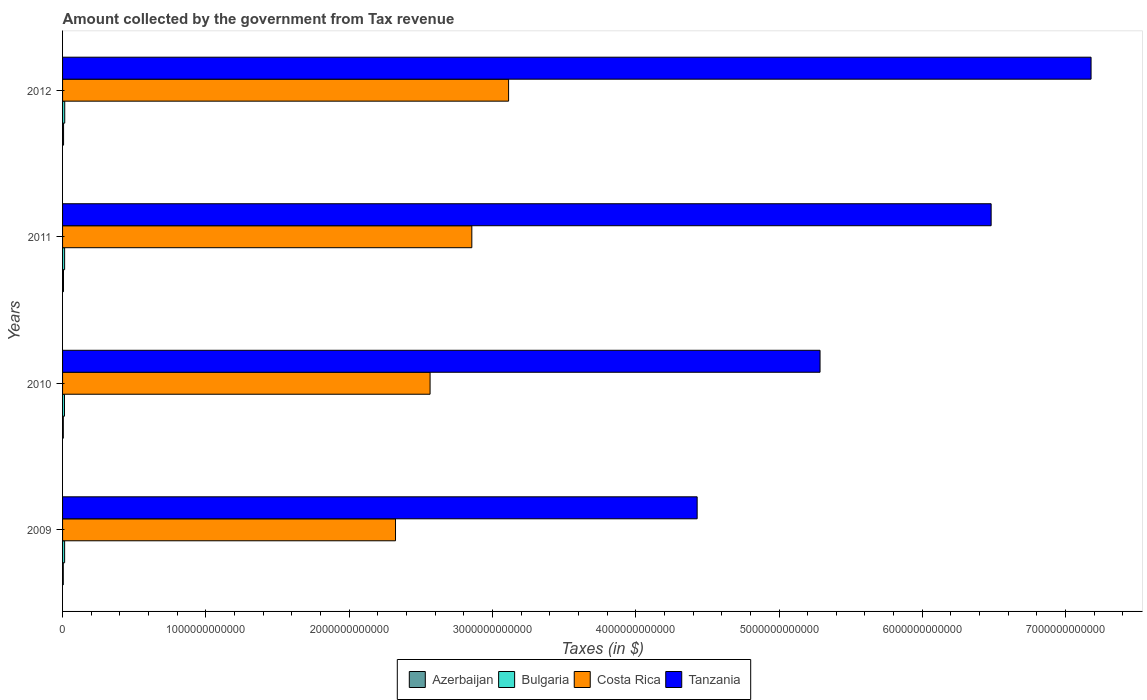How many different coloured bars are there?
Give a very brief answer. 4. How many groups of bars are there?
Ensure brevity in your answer.  4. Are the number of bars per tick equal to the number of legend labels?
Provide a short and direct response. Yes. What is the label of the 4th group of bars from the top?
Give a very brief answer. 2009. In how many cases, is the number of bars for a given year not equal to the number of legend labels?
Offer a terse response. 0. What is the amount collected by the government from tax revenue in Bulgaria in 2012?
Your answer should be compact. 1.52e+1. Across all years, what is the maximum amount collected by the government from tax revenue in Costa Rica?
Your response must be concise. 3.11e+12. Across all years, what is the minimum amount collected by the government from tax revenue in Bulgaria?
Make the answer very short. 1.35e+1. In which year was the amount collected by the government from tax revenue in Costa Rica minimum?
Offer a very short reply. 2009. What is the total amount collected by the government from tax revenue in Bulgaria in the graph?
Keep it short and to the point. 5.74e+1. What is the difference between the amount collected by the government from tax revenue in Bulgaria in 2009 and that in 2011?
Provide a short and direct response. 9.09e+06. What is the difference between the amount collected by the government from tax revenue in Azerbaijan in 2010 and the amount collected by the government from tax revenue in Bulgaria in 2012?
Keep it short and to the point. -1.00e+1. What is the average amount collected by the government from tax revenue in Bulgaria per year?
Offer a terse response. 1.43e+1. In the year 2012, what is the difference between the amount collected by the government from tax revenue in Costa Rica and amount collected by the government from tax revenue in Bulgaria?
Ensure brevity in your answer.  3.10e+12. What is the ratio of the amount collected by the government from tax revenue in Azerbaijan in 2009 to that in 2011?
Your response must be concise. 0.79. Is the amount collected by the government from tax revenue in Azerbaijan in 2009 less than that in 2011?
Your answer should be very brief. Yes. What is the difference between the highest and the second highest amount collected by the government from tax revenue in Azerbaijan?
Your answer should be very brief. 6.29e+08. What is the difference between the highest and the lowest amount collected by the government from tax revenue in Bulgaria?
Your answer should be compact. 1.67e+09. In how many years, is the amount collected by the government from tax revenue in Bulgaria greater than the average amount collected by the government from tax revenue in Bulgaria taken over all years?
Your answer should be very brief. 3. What does the 4th bar from the top in 2012 represents?
Keep it short and to the point. Azerbaijan. What does the 1st bar from the bottom in 2012 represents?
Offer a terse response. Azerbaijan. Is it the case that in every year, the sum of the amount collected by the government from tax revenue in Bulgaria and amount collected by the government from tax revenue in Tanzania is greater than the amount collected by the government from tax revenue in Costa Rica?
Your answer should be very brief. Yes. How many bars are there?
Make the answer very short. 16. Are all the bars in the graph horizontal?
Your response must be concise. Yes. How many years are there in the graph?
Give a very brief answer. 4. What is the difference between two consecutive major ticks on the X-axis?
Your answer should be compact. 1.00e+12. What is the title of the graph?
Make the answer very short. Amount collected by the government from Tax revenue. Does "San Marino" appear as one of the legend labels in the graph?
Give a very brief answer. No. What is the label or title of the X-axis?
Your response must be concise. Taxes (in $). What is the label or title of the Y-axis?
Ensure brevity in your answer.  Years. What is the Taxes (in $) in Azerbaijan in 2009?
Give a very brief answer. 5.02e+09. What is the Taxes (in $) in Bulgaria in 2009?
Provide a succinct answer. 1.44e+1. What is the Taxes (in $) of Costa Rica in 2009?
Your answer should be compact. 2.32e+12. What is the Taxes (in $) of Tanzania in 2009?
Your response must be concise. 4.43e+12. What is the Taxes (in $) of Azerbaijan in 2010?
Your response must be concise. 5.16e+09. What is the Taxes (in $) of Bulgaria in 2010?
Your answer should be very brief. 1.35e+1. What is the Taxes (in $) in Costa Rica in 2010?
Your response must be concise. 2.56e+12. What is the Taxes (in $) of Tanzania in 2010?
Give a very brief answer. 5.29e+12. What is the Taxes (in $) in Azerbaijan in 2011?
Give a very brief answer. 6.37e+09. What is the Taxes (in $) in Bulgaria in 2011?
Give a very brief answer. 1.43e+1. What is the Taxes (in $) in Costa Rica in 2011?
Your answer should be compact. 2.86e+12. What is the Taxes (in $) of Tanzania in 2011?
Ensure brevity in your answer.  6.48e+12. What is the Taxes (in $) of Azerbaijan in 2012?
Give a very brief answer. 7.00e+09. What is the Taxes (in $) in Bulgaria in 2012?
Keep it short and to the point. 1.52e+1. What is the Taxes (in $) in Costa Rica in 2012?
Provide a succinct answer. 3.11e+12. What is the Taxes (in $) in Tanzania in 2012?
Your answer should be very brief. 7.18e+12. Across all years, what is the maximum Taxes (in $) in Azerbaijan?
Provide a succinct answer. 7.00e+09. Across all years, what is the maximum Taxes (in $) in Bulgaria?
Ensure brevity in your answer.  1.52e+1. Across all years, what is the maximum Taxes (in $) in Costa Rica?
Give a very brief answer. 3.11e+12. Across all years, what is the maximum Taxes (in $) in Tanzania?
Ensure brevity in your answer.  7.18e+12. Across all years, what is the minimum Taxes (in $) of Azerbaijan?
Your answer should be very brief. 5.02e+09. Across all years, what is the minimum Taxes (in $) of Bulgaria?
Your answer should be compact. 1.35e+1. Across all years, what is the minimum Taxes (in $) of Costa Rica?
Provide a short and direct response. 2.32e+12. Across all years, what is the minimum Taxes (in $) of Tanzania?
Your answer should be compact. 4.43e+12. What is the total Taxes (in $) in Azerbaijan in the graph?
Make the answer very short. 2.35e+1. What is the total Taxes (in $) in Bulgaria in the graph?
Your answer should be very brief. 5.74e+1. What is the total Taxes (in $) of Costa Rica in the graph?
Your answer should be compact. 1.09e+13. What is the total Taxes (in $) in Tanzania in the graph?
Keep it short and to the point. 2.34e+13. What is the difference between the Taxes (in $) of Azerbaijan in 2009 and that in 2010?
Provide a short and direct response. -1.41e+08. What is the difference between the Taxes (in $) in Bulgaria in 2009 and that in 2010?
Provide a short and direct response. 8.58e+08. What is the difference between the Taxes (in $) of Costa Rica in 2009 and that in 2010?
Offer a terse response. -2.41e+11. What is the difference between the Taxes (in $) of Tanzania in 2009 and that in 2010?
Your answer should be very brief. -8.58e+11. What is the difference between the Taxes (in $) in Azerbaijan in 2009 and that in 2011?
Provide a short and direct response. -1.34e+09. What is the difference between the Taxes (in $) in Bulgaria in 2009 and that in 2011?
Provide a short and direct response. 9.09e+06. What is the difference between the Taxes (in $) of Costa Rica in 2009 and that in 2011?
Ensure brevity in your answer.  -5.33e+11. What is the difference between the Taxes (in $) in Tanzania in 2009 and that in 2011?
Ensure brevity in your answer.  -2.05e+12. What is the difference between the Taxes (in $) of Azerbaijan in 2009 and that in 2012?
Offer a terse response. -1.97e+09. What is the difference between the Taxes (in $) of Bulgaria in 2009 and that in 2012?
Offer a very short reply. -8.16e+08. What is the difference between the Taxes (in $) in Costa Rica in 2009 and that in 2012?
Offer a terse response. -7.89e+11. What is the difference between the Taxes (in $) in Tanzania in 2009 and that in 2012?
Make the answer very short. -2.75e+12. What is the difference between the Taxes (in $) in Azerbaijan in 2010 and that in 2011?
Make the answer very short. -1.20e+09. What is the difference between the Taxes (in $) of Bulgaria in 2010 and that in 2011?
Make the answer very short. -8.49e+08. What is the difference between the Taxes (in $) in Costa Rica in 2010 and that in 2011?
Offer a very short reply. -2.91e+11. What is the difference between the Taxes (in $) in Tanzania in 2010 and that in 2011?
Offer a very short reply. -1.19e+12. What is the difference between the Taxes (in $) in Azerbaijan in 2010 and that in 2012?
Keep it short and to the point. -1.83e+09. What is the difference between the Taxes (in $) of Bulgaria in 2010 and that in 2012?
Keep it short and to the point. -1.67e+09. What is the difference between the Taxes (in $) in Costa Rica in 2010 and that in 2012?
Your answer should be compact. -5.48e+11. What is the difference between the Taxes (in $) in Tanzania in 2010 and that in 2012?
Provide a short and direct response. -1.89e+12. What is the difference between the Taxes (in $) in Azerbaijan in 2011 and that in 2012?
Your response must be concise. -6.29e+08. What is the difference between the Taxes (in $) of Bulgaria in 2011 and that in 2012?
Provide a succinct answer. -8.25e+08. What is the difference between the Taxes (in $) in Costa Rica in 2011 and that in 2012?
Offer a very short reply. -2.57e+11. What is the difference between the Taxes (in $) in Tanzania in 2011 and that in 2012?
Offer a terse response. -6.97e+11. What is the difference between the Taxes (in $) in Azerbaijan in 2009 and the Taxes (in $) in Bulgaria in 2010?
Keep it short and to the point. -8.48e+09. What is the difference between the Taxes (in $) in Azerbaijan in 2009 and the Taxes (in $) in Costa Rica in 2010?
Ensure brevity in your answer.  -2.56e+12. What is the difference between the Taxes (in $) of Azerbaijan in 2009 and the Taxes (in $) of Tanzania in 2010?
Provide a succinct answer. -5.28e+12. What is the difference between the Taxes (in $) of Bulgaria in 2009 and the Taxes (in $) of Costa Rica in 2010?
Give a very brief answer. -2.55e+12. What is the difference between the Taxes (in $) in Bulgaria in 2009 and the Taxes (in $) in Tanzania in 2010?
Keep it short and to the point. -5.27e+12. What is the difference between the Taxes (in $) in Costa Rica in 2009 and the Taxes (in $) in Tanzania in 2010?
Ensure brevity in your answer.  -2.96e+12. What is the difference between the Taxes (in $) of Azerbaijan in 2009 and the Taxes (in $) of Bulgaria in 2011?
Keep it short and to the point. -9.33e+09. What is the difference between the Taxes (in $) of Azerbaijan in 2009 and the Taxes (in $) of Costa Rica in 2011?
Provide a succinct answer. -2.85e+12. What is the difference between the Taxes (in $) of Azerbaijan in 2009 and the Taxes (in $) of Tanzania in 2011?
Give a very brief answer. -6.48e+12. What is the difference between the Taxes (in $) of Bulgaria in 2009 and the Taxes (in $) of Costa Rica in 2011?
Your answer should be compact. -2.84e+12. What is the difference between the Taxes (in $) in Bulgaria in 2009 and the Taxes (in $) in Tanzania in 2011?
Keep it short and to the point. -6.47e+12. What is the difference between the Taxes (in $) of Costa Rica in 2009 and the Taxes (in $) of Tanzania in 2011?
Provide a short and direct response. -4.16e+12. What is the difference between the Taxes (in $) in Azerbaijan in 2009 and the Taxes (in $) in Bulgaria in 2012?
Your answer should be compact. -1.02e+1. What is the difference between the Taxes (in $) of Azerbaijan in 2009 and the Taxes (in $) of Costa Rica in 2012?
Keep it short and to the point. -3.11e+12. What is the difference between the Taxes (in $) in Azerbaijan in 2009 and the Taxes (in $) in Tanzania in 2012?
Provide a succinct answer. -7.17e+12. What is the difference between the Taxes (in $) in Bulgaria in 2009 and the Taxes (in $) in Costa Rica in 2012?
Your answer should be very brief. -3.10e+12. What is the difference between the Taxes (in $) of Bulgaria in 2009 and the Taxes (in $) of Tanzania in 2012?
Ensure brevity in your answer.  -7.16e+12. What is the difference between the Taxes (in $) in Costa Rica in 2009 and the Taxes (in $) in Tanzania in 2012?
Keep it short and to the point. -4.85e+12. What is the difference between the Taxes (in $) of Azerbaijan in 2010 and the Taxes (in $) of Bulgaria in 2011?
Provide a succinct answer. -9.19e+09. What is the difference between the Taxes (in $) of Azerbaijan in 2010 and the Taxes (in $) of Costa Rica in 2011?
Offer a terse response. -2.85e+12. What is the difference between the Taxes (in $) in Azerbaijan in 2010 and the Taxes (in $) in Tanzania in 2011?
Provide a succinct answer. -6.48e+12. What is the difference between the Taxes (in $) of Bulgaria in 2010 and the Taxes (in $) of Costa Rica in 2011?
Your answer should be very brief. -2.84e+12. What is the difference between the Taxes (in $) of Bulgaria in 2010 and the Taxes (in $) of Tanzania in 2011?
Give a very brief answer. -6.47e+12. What is the difference between the Taxes (in $) of Costa Rica in 2010 and the Taxes (in $) of Tanzania in 2011?
Keep it short and to the point. -3.92e+12. What is the difference between the Taxes (in $) of Azerbaijan in 2010 and the Taxes (in $) of Bulgaria in 2012?
Give a very brief answer. -1.00e+1. What is the difference between the Taxes (in $) of Azerbaijan in 2010 and the Taxes (in $) of Costa Rica in 2012?
Provide a succinct answer. -3.11e+12. What is the difference between the Taxes (in $) in Azerbaijan in 2010 and the Taxes (in $) in Tanzania in 2012?
Your answer should be compact. -7.17e+12. What is the difference between the Taxes (in $) of Bulgaria in 2010 and the Taxes (in $) of Costa Rica in 2012?
Give a very brief answer. -3.10e+12. What is the difference between the Taxes (in $) in Bulgaria in 2010 and the Taxes (in $) in Tanzania in 2012?
Your response must be concise. -7.16e+12. What is the difference between the Taxes (in $) of Costa Rica in 2010 and the Taxes (in $) of Tanzania in 2012?
Your response must be concise. -4.61e+12. What is the difference between the Taxes (in $) of Azerbaijan in 2011 and the Taxes (in $) of Bulgaria in 2012?
Your answer should be very brief. -8.81e+09. What is the difference between the Taxes (in $) of Azerbaijan in 2011 and the Taxes (in $) of Costa Rica in 2012?
Provide a succinct answer. -3.11e+12. What is the difference between the Taxes (in $) in Azerbaijan in 2011 and the Taxes (in $) in Tanzania in 2012?
Your response must be concise. -7.17e+12. What is the difference between the Taxes (in $) of Bulgaria in 2011 and the Taxes (in $) of Costa Rica in 2012?
Your response must be concise. -3.10e+12. What is the difference between the Taxes (in $) in Bulgaria in 2011 and the Taxes (in $) in Tanzania in 2012?
Provide a short and direct response. -7.16e+12. What is the difference between the Taxes (in $) in Costa Rica in 2011 and the Taxes (in $) in Tanzania in 2012?
Your response must be concise. -4.32e+12. What is the average Taxes (in $) in Azerbaijan per year?
Give a very brief answer. 5.89e+09. What is the average Taxes (in $) in Bulgaria per year?
Your response must be concise. 1.43e+1. What is the average Taxes (in $) in Costa Rica per year?
Make the answer very short. 2.71e+12. What is the average Taxes (in $) in Tanzania per year?
Your answer should be compact. 5.84e+12. In the year 2009, what is the difference between the Taxes (in $) in Azerbaijan and Taxes (in $) in Bulgaria?
Your answer should be compact. -9.34e+09. In the year 2009, what is the difference between the Taxes (in $) of Azerbaijan and Taxes (in $) of Costa Rica?
Keep it short and to the point. -2.32e+12. In the year 2009, what is the difference between the Taxes (in $) of Azerbaijan and Taxes (in $) of Tanzania?
Ensure brevity in your answer.  -4.42e+12. In the year 2009, what is the difference between the Taxes (in $) of Bulgaria and Taxes (in $) of Costa Rica?
Your response must be concise. -2.31e+12. In the year 2009, what is the difference between the Taxes (in $) of Bulgaria and Taxes (in $) of Tanzania?
Offer a terse response. -4.41e+12. In the year 2009, what is the difference between the Taxes (in $) of Costa Rica and Taxes (in $) of Tanzania?
Your answer should be very brief. -2.11e+12. In the year 2010, what is the difference between the Taxes (in $) of Azerbaijan and Taxes (in $) of Bulgaria?
Keep it short and to the point. -8.34e+09. In the year 2010, what is the difference between the Taxes (in $) in Azerbaijan and Taxes (in $) in Costa Rica?
Make the answer very short. -2.56e+12. In the year 2010, what is the difference between the Taxes (in $) of Azerbaijan and Taxes (in $) of Tanzania?
Your response must be concise. -5.28e+12. In the year 2010, what is the difference between the Taxes (in $) in Bulgaria and Taxes (in $) in Costa Rica?
Offer a terse response. -2.55e+12. In the year 2010, what is the difference between the Taxes (in $) in Bulgaria and Taxes (in $) in Tanzania?
Offer a very short reply. -5.27e+12. In the year 2010, what is the difference between the Taxes (in $) of Costa Rica and Taxes (in $) of Tanzania?
Your answer should be compact. -2.72e+12. In the year 2011, what is the difference between the Taxes (in $) in Azerbaijan and Taxes (in $) in Bulgaria?
Your answer should be compact. -7.98e+09. In the year 2011, what is the difference between the Taxes (in $) of Azerbaijan and Taxes (in $) of Costa Rica?
Your response must be concise. -2.85e+12. In the year 2011, what is the difference between the Taxes (in $) in Azerbaijan and Taxes (in $) in Tanzania?
Your answer should be compact. -6.47e+12. In the year 2011, what is the difference between the Taxes (in $) in Bulgaria and Taxes (in $) in Costa Rica?
Provide a short and direct response. -2.84e+12. In the year 2011, what is the difference between the Taxes (in $) of Bulgaria and Taxes (in $) of Tanzania?
Make the answer very short. -6.47e+12. In the year 2011, what is the difference between the Taxes (in $) in Costa Rica and Taxes (in $) in Tanzania?
Your answer should be very brief. -3.62e+12. In the year 2012, what is the difference between the Taxes (in $) in Azerbaijan and Taxes (in $) in Bulgaria?
Provide a succinct answer. -8.18e+09. In the year 2012, what is the difference between the Taxes (in $) in Azerbaijan and Taxes (in $) in Costa Rica?
Ensure brevity in your answer.  -3.11e+12. In the year 2012, what is the difference between the Taxes (in $) of Azerbaijan and Taxes (in $) of Tanzania?
Give a very brief answer. -7.17e+12. In the year 2012, what is the difference between the Taxes (in $) of Bulgaria and Taxes (in $) of Costa Rica?
Provide a succinct answer. -3.10e+12. In the year 2012, what is the difference between the Taxes (in $) in Bulgaria and Taxes (in $) in Tanzania?
Ensure brevity in your answer.  -7.16e+12. In the year 2012, what is the difference between the Taxes (in $) of Costa Rica and Taxes (in $) of Tanzania?
Keep it short and to the point. -4.07e+12. What is the ratio of the Taxes (in $) in Azerbaijan in 2009 to that in 2010?
Make the answer very short. 0.97. What is the ratio of the Taxes (in $) in Bulgaria in 2009 to that in 2010?
Offer a very short reply. 1.06. What is the ratio of the Taxes (in $) of Costa Rica in 2009 to that in 2010?
Provide a short and direct response. 0.91. What is the ratio of the Taxes (in $) of Tanzania in 2009 to that in 2010?
Offer a very short reply. 0.84. What is the ratio of the Taxes (in $) in Azerbaijan in 2009 to that in 2011?
Keep it short and to the point. 0.79. What is the ratio of the Taxes (in $) in Costa Rica in 2009 to that in 2011?
Offer a terse response. 0.81. What is the ratio of the Taxes (in $) of Tanzania in 2009 to that in 2011?
Your answer should be very brief. 0.68. What is the ratio of the Taxes (in $) in Azerbaijan in 2009 to that in 2012?
Give a very brief answer. 0.72. What is the ratio of the Taxes (in $) in Bulgaria in 2009 to that in 2012?
Your response must be concise. 0.95. What is the ratio of the Taxes (in $) in Costa Rica in 2009 to that in 2012?
Make the answer very short. 0.75. What is the ratio of the Taxes (in $) in Tanzania in 2009 to that in 2012?
Make the answer very short. 0.62. What is the ratio of the Taxes (in $) in Azerbaijan in 2010 to that in 2011?
Your answer should be very brief. 0.81. What is the ratio of the Taxes (in $) in Bulgaria in 2010 to that in 2011?
Offer a terse response. 0.94. What is the ratio of the Taxes (in $) in Costa Rica in 2010 to that in 2011?
Provide a short and direct response. 0.9. What is the ratio of the Taxes (in $) in Tanzania in 2010 to that in 2011?
Give a very brief answer. 0.82. What is the ratio of the Taxes (in $) of Azerbaijan in 2010 to that in 2012?
Give a very brief answer. 0.74. What is the ratio of the Taxes (in $) in Bulgaria in 2010 to that in 2012?
Offer a very short reply. 0.89. What is the ratio of the Taxes (in $) of Costa Rica in 2010 to that in 2012?
Offer a terse response. 0.82. What is the ratio of the Taxes (in $) in Tanzania in 2010 to that in 2012?
Ensure brevity in your answer.  0.74. What is the ratio of the Taxes (in $) in Azerbaijan in 2011 to that in 2012?
Make the answer very short. 0.91. What is the ratio of the Taxes (in $) of Bulgaria in 2011 to that in 2012?
Keep it short and to the point. 0.95. What is the ratio of the Taxes (in $) in Costa Rica in 2011 to that in 2012?
Your answer should be very brief. 0.92. What is the ratio of the Taxes (in $) of Tanzania in 2011 to that in 2012?
Provide a succinct answer. 0.9. What is the difference between the highest and the second highest Taxes (in $) in Azerbaijan?
Make the answer very short. 6.29e+08. What is the difference between the highest and the second highest Taxes (in $) of Bulgaria?
Ensure brevity in your answer.  8.16e+08. What is the difference between the highest and the second highest Taxes (in $) of Costa Rica?
Make the answer very short. 2.57e+11. What is the difference between the highest and the second highest Taxes (in $) of Tanzania?
Ensure brevity in your answer.  6.97e+11. What is the difference between the highest and the lowest Taxes (in $) of Azerbaijan?
Ensure brevity in your answer.  1.97e+09. What is the difference between the highest and the lowest Taxes (in $) of Bulgaria?
Offer a very short reply. 1.67e+09. What is the difference between the highest and the lowest Taxes (in $) in Costa Rica?
Your response must be concise. 7.89e+11. What is the difference between the highest and the lowest Taxes (in $) of Tanzania?
Provide a short and direct response. 2.75e+12. 